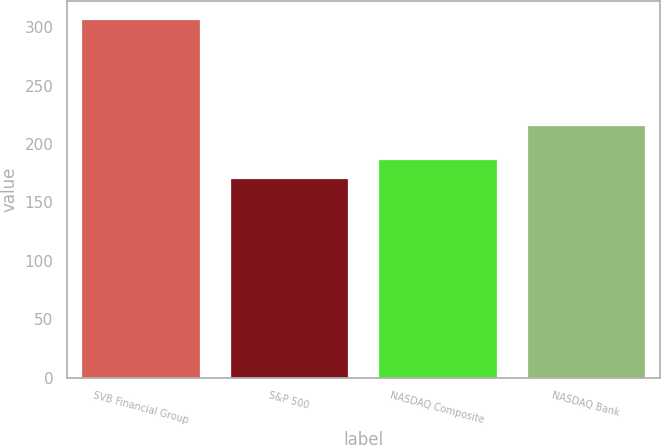<chart> <loc_0><loc_0><loc_500><loc_500><bar_chart><fcel>SVB Financial Group<fcel>S&P 500<fcel>NASDAQ Composite<fcel>NASDAQ Bank<nl><fcel>306.7<fcel>170.84<fcel>187.19<fcel>216.24<nl></chart> 